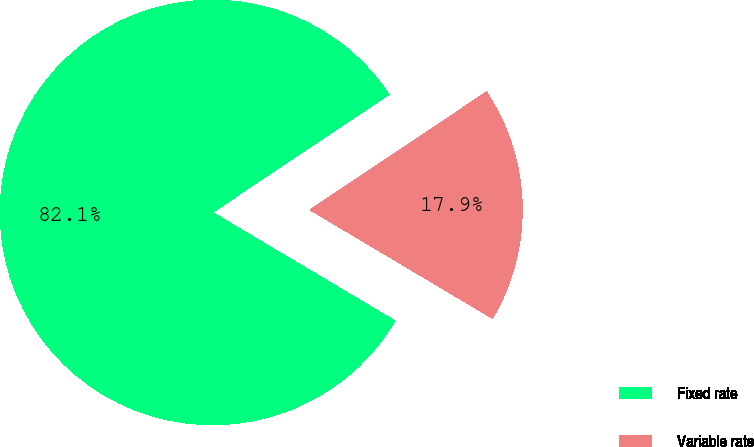Convert chart. <chart><loc_0><loc_0><loc_500><loc_500><pie_chart><fcel>Fixed rate<fcel>Variable rate<nl><fcel>82.09%<fcel>17.91%<nl></chart> 